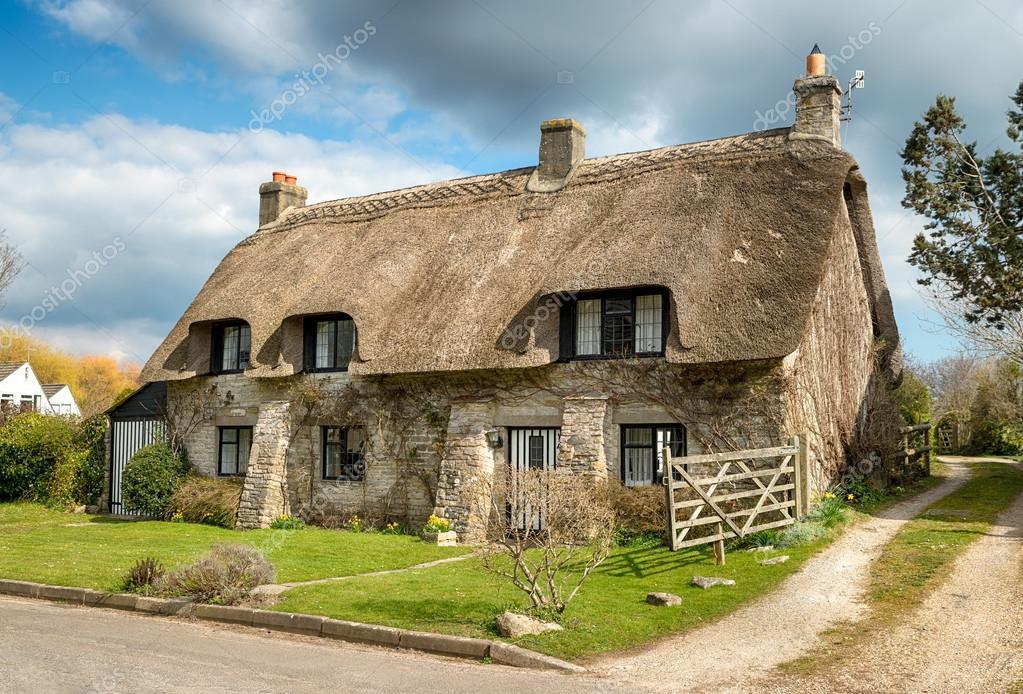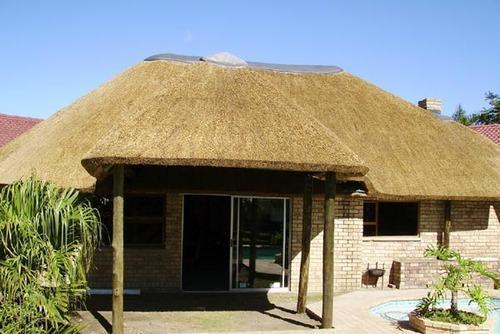The first image is the image on the left, the second image is the image on the right. Evaluate the accuracy of this statement regarding the images: "One image shows a building with a thatched roof that does not extend all the way down its front, and the roof has three notched sections to accommodate upper story windows.". Is it true? Answer yes or no. Yes. The first image is the image on the left, the second image is the image on the right. Analyze the images presented: Is the assertion "A fence runs alongside the building in the image on the left." valid? Answer yes or no. Yes. 